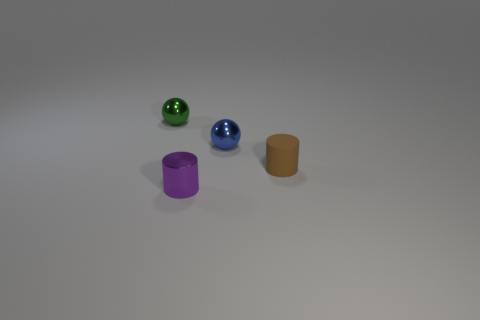Can you estimate the relative sizes of the objects in the image? While it's difficult to provide exact dimensions without a reference, the objects are consistently scaled to one another. Starting from the left, the sizes decrease with the green sphere being the largest, followed by the blue sphere, the purple cylinder, and the tan-colored cylinder being the smallest in visible height. 